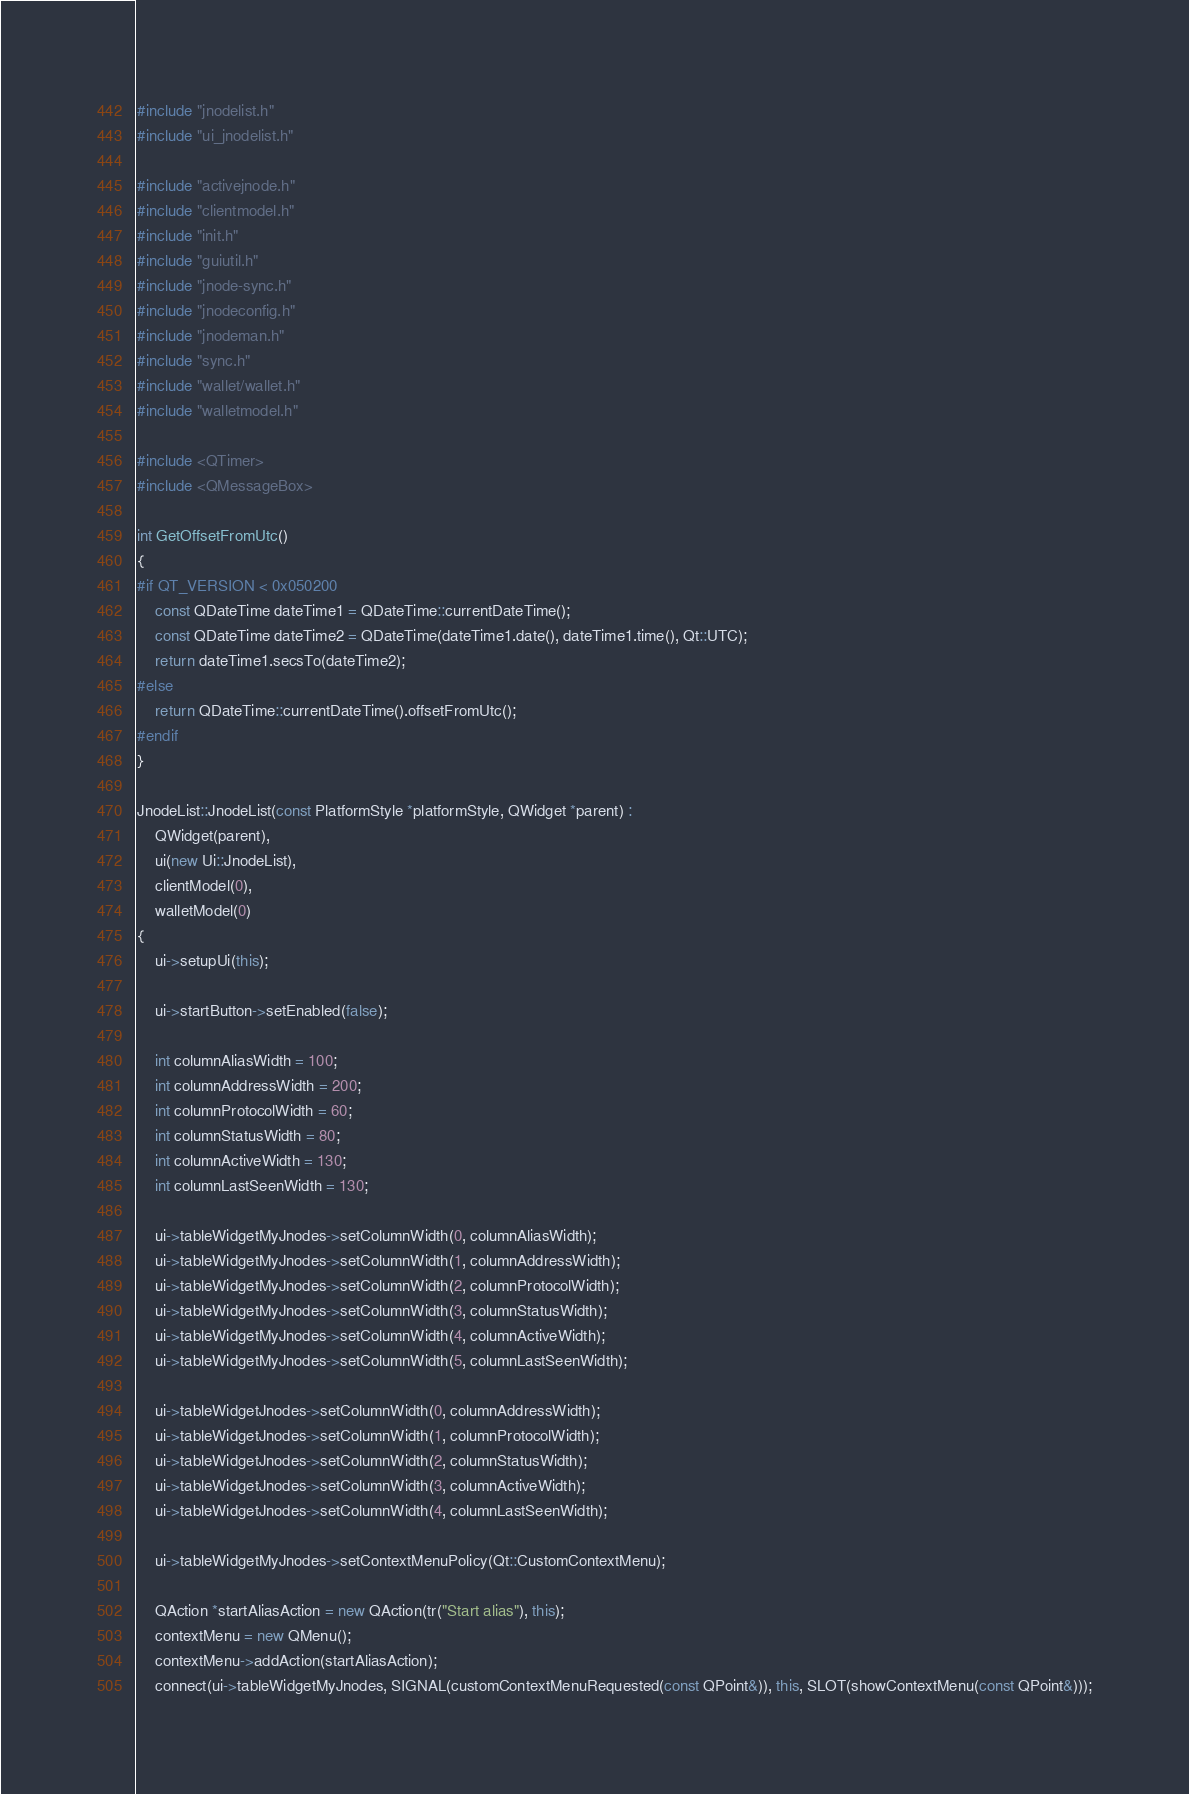Convert code to text. <code><loc_0><loc_0><loc_500><loc_500><_C++_>#include "jnodelist.h"
#include "ui_jnodelist.h"

#include "activejnode.h"
#include "clientmodel.h"
#include "init.h"
#include "guiutil.h"
#include "jnode-sync.h"
#include "jnodeconfig.h"
#include "jnodeman.h"
#include "sync.h"
#include "wallet/wallet.h"
#include "walletmodel.h"

#include <QTimer>
#include <QMessageBox>

int GetOffsetFromUtc()
{
#if QT_VERSION < 0x050200
    const QDateTime dateTime1 = QDateTime::currentDateTime();
    const QDateTime dateTime2 = QDateTime(dateTime1.date(), dateTime1.time(), Qt::UTC);
    return dateTime1.secsTo(dateTime2);
#else
    return QDateTime::currentDateTime().offsetFromUtc();
#endif
}

JnodeList::JnodeList(const PlatformStyle *platformStyle, QWidget *parent) :
    QWidget(parent),
    ui(new Ui::JnodeList),
    clientModel(0),
    walletModel(0)
{
    ui->setupUi(this);

    ui->startButton->setEnabled(false);

    int columnAliasWidth = 100;
    int columnAddressWidth = 200;
    int columnProtocolWidth = 60;
    int columnStatusWidth = 80;
    int columnActiveWidth = 130;
    int columnLastSeenWidth = 130;

    ui->tableWidgetMyJnodes->setColumnWidth(0, columnAliasWidth);
    ui->tableWidgetMyJnodes->setColumnWidth(1, columnAddressWidth);
    ui->tableWidgetMyJnodes->setColumnWidth(2, columnProtocolWidth);
    ui->tableWidgetMyJnodes->setColumnWidth(3, columnStatusWidth);
    ui->tableWidgetMyJnodes->setColumnWidth(4, columnActiveWidth);
    ui->tableWidgetMyJnodes->setColumnWidth(5, columnLastSeenWidth);

    ui->tableWidgetJnodes->setColumnWidth(0, columnAddressWidth);
    ui->tableWidgetJnodes->setColumnWidth(1, columnProtocolWidth);
    ui->tableWidgetJnodes->setColumnWidth(2, columnStatusWidth);
    ui->tableWidgetJnodes->setColumnWidth(3, columnActiveWidth);
    ui->tableWidgetJnodes->setColumnWidth(4, columnLastSeenWidth);

    ui->tableWidgetMyJnodes->setContextMenuPolicy(Qt::CustomContextMenu);

    QAction *startAliasAction = new QAction(tr("Start alias"), this);
    contextMenu = new QMenu();
    contextMenu->addAction(startAliasAction);
    connect(ui->tableWidgetMyJnodes, SIGNAL(customContextMenuRequested(const QPoint&)), this, SLOT(showContextMenu(const QPoint&)));</code> 